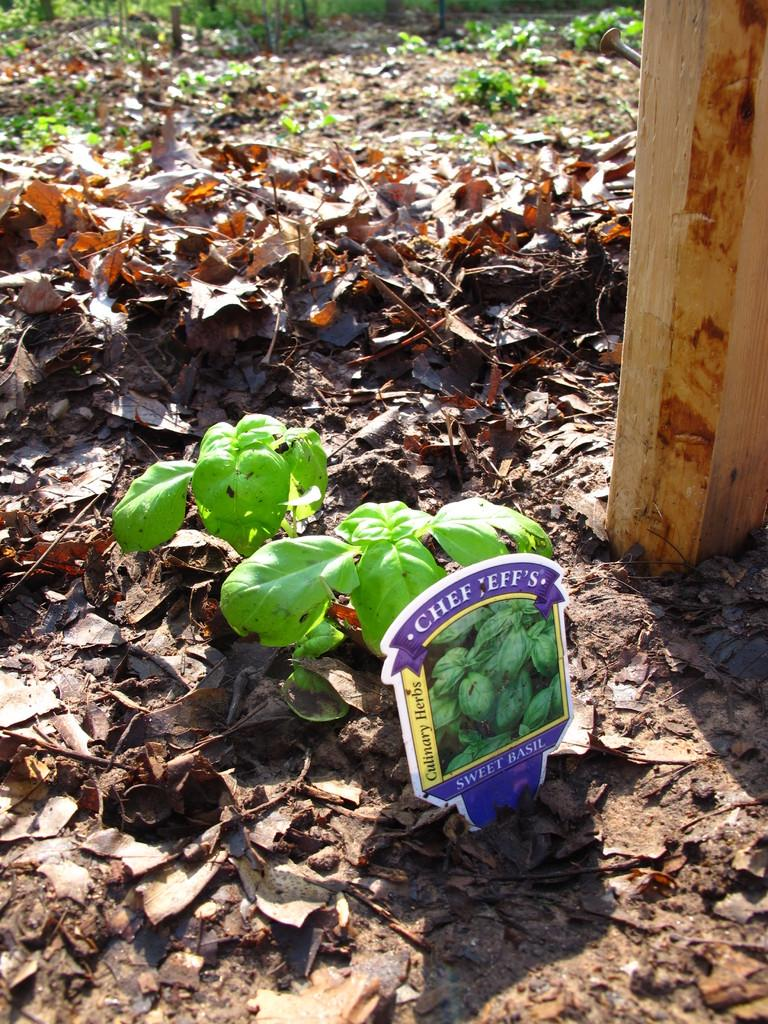What is the main object in the image? There is a name board in the image. What type of material are the wooden objects made of? The wooden objects in the image are made of wood. What can be seen scattered on the ground in the image? There are dried leaves in the image. What type of vegetation is present on the ground in the image? There are plants on the ground in the image. What type of fruit is hanging from the name board in the image? There is no fruit hanging from the name board in the image. How many balls are visible in the image? There are no balls present in the image. 